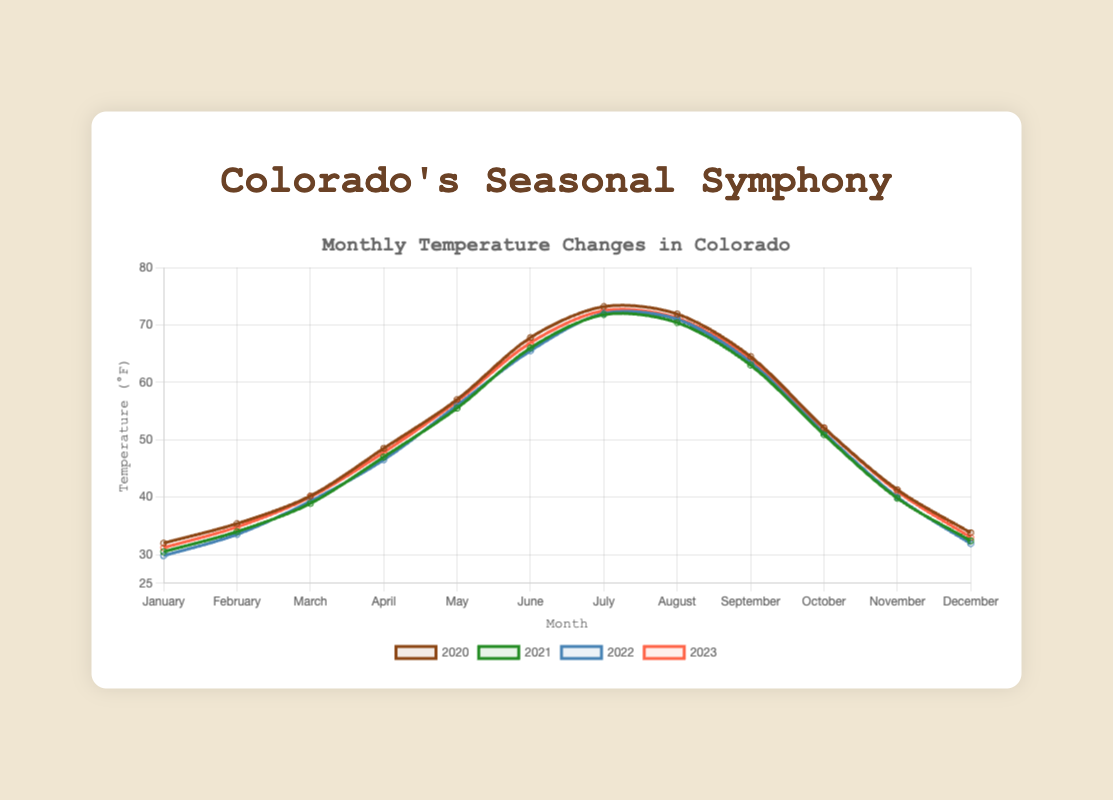What month had the lowest average temperature in 2022? To find the lowest average temperature in 2022, look through the 2022 data points and identify the minimum value. January has the lowest with an average temperature of 29.8°F.
Answer: January Which year had the highest average temperature in July? Compare the average temperatures for July across the years 2020, 2021, 2022, and 2023. 2020 had the highest average temperature at 73.2°F.
Answer: 2020 How much did the average temperature change from January 2020 to January 2023? Subtract the average temperature of January 2020 from January 2023. The difference is 31.2°F - 32.0°F = -0.8°F.
Answer: -0.8°F What's the average temperature across all years for April? Calculate the average of the April temperatures for 2020, 2021, 2022, and 2023. The average is (48.5 + 47.0 + 46.5 + 47.8) / 4 = 47.45°F.
Answer: 47.45°F In which month did 2023 have the closest average temperature to 2020? Check the average temperatures for each month in 2020 and 2023, then find the month with the smallest difference. August has the smallest difference with 0.7°F (71.9 - 71.2).
Answer: August What's the overall trend in average temperatures from January to December in 2021? Look at the line for 2021 from January to December. The general trend shows decreasing from January to February, then increasing towards July, and again decreasing towards December.
Answer: General increase to mid-year, then decrease Compare May average temperatures for all four years. List them in ascending order. List the average temperatures for May from each year and sort them: 55.5 (2021), 56.0 (2022), 56.7 (2023), 57.0 (2020).
Answer: 55.5°F, 56.0°F, 56.7°F, 57.0°F What is the combined average temperature for June in 2021 and 2022? Add 2021 and 2022 June temperatures and divide by 2. The combined average is (66.0 + 65.5) / 2 = 65.75°F.
Answer: 65.75°F 